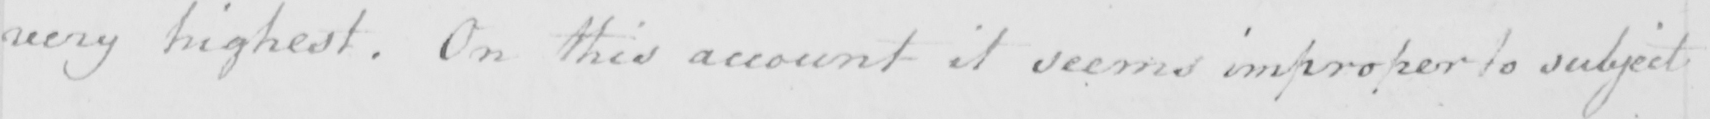What does this handwritten line say? very highest . On this account it seems improper to subject 